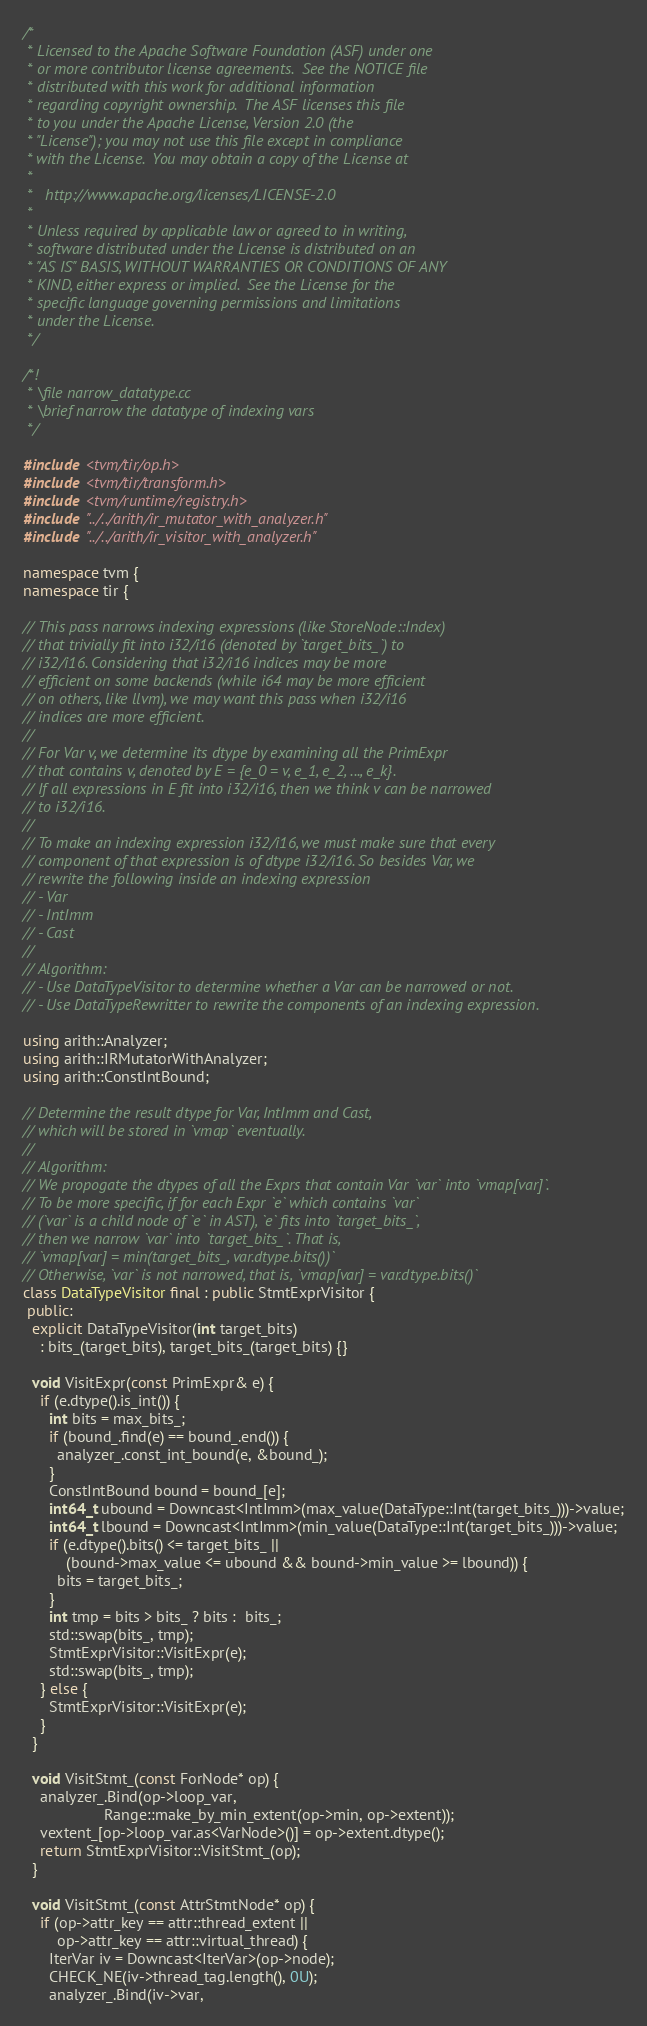Convert code to text. <code><loc_0><loc_0><loc_500><loc_500><_C++_>/*
 * Licensed to the Apache Software Foundation (ASF) under one
 * or more contributor license agreements.  See the NOTICE file
 * distributed with this work for additional information
 * regarding copyright ownership.  The ASF licenses this file
 * to you under the Apache License, Version 2.0 (the
 * "License"); you may not use this file except in compliance
 * with the License.  You may obtain a copy of the License at
 *
 *   http://www.apache.org/licenses/LICENSE-2.0
 *
 * Unless required by applicable law or agreed to in writing,
 * software distributed under the License is distributed on an
 * "AS IS" BASIS, WITHOUT WARRANTIES OR CONDITIONS OF ANY
 * KIND, either express or implied.  See the License for the
 * specific language governing permissions and limitations
 * under the License.
 */

/*!
 * \file narrow_datatype.cc
 * \brief narrow the datatype of indexing vars
 */

#include <tvm/tir/op.h>
#include <tvm/tir/transform.h>
#include <tvm/runtime/registry.h>
#include "../../arith/ir_mutator_with_analyzer.h"
#include "../../arith/ir_visitor_with_analyzer.h"

namespace tvm {
namespace tir {

// This pass narrows indexing expressions (like StoreNode::Index)
// that trivially fit into i32/i16 (denoted by `target_bits_`) to
// i32/i16. Considering that i32/i16 indices may be more
// efficient on some backends (while i64 may be more efficient
// on others, like llvm), we may want this pass when i32/i16
// indices are more efficient.
//
// For Var v, we determine its dtype by examining all the PrimExpr
// that contains v, denoted by E = {e_0 = v, e_1, e_2, ..., e_k}.
// If all expressions in E fit into i32/i16, then we think v can be narrowed
// to i32/i16.
//
// To make an indexing expression i32/i16, we must make sure that every
// component of that expression is of dtype i32/i16. So besides Var, we
// rewrite the following inside an indexing expression
// - Var
// - IntImm
// - Cast
//
// Algorithm:
// - Use DataTypeVisitor to determine whether a Var can be narrowed or not.
// - Use DataTypeRewritter to rewrite the components of an indexing expression.

using arith::Analyzer;
using arith::IRMutatorWithAnalyzer;
using arith::ConstIntBound;

// Determine the result dtype for Var, IntImm and Cast,
// which will be stored in `vmap` eventually.
//
// Algorithm:
// We propogate the dtypes of all the Exprs that contain Var `var` into `vmap[var]`.
// To be more specific, if for each Expr `e` which contains `var`
// (`var` is a child node of `e` in AST), `e` fits into `target_bits_`,
// then we narrow `var` into `target_bits_`. That is,
// `vmap[var] = min(target_bits_, var.dtype.bits())`
// Otherwise, `var` is not narrowed, that is, `vmap[var] = var.dtype.bits()`
class DataTypeVisitor final : public StmtExprVisitor {
 public:
  explicit DataTypeVisitor(int target_bits)
    : bits_(target_bits), target_bits_(target_bits) {}

  void VisitExpr(const PrimExpr& e) {
    if (e.dtype().is_int()) {
      int bits = max_bits_;
      if (bound_.find(e) == bound_.end()) {
        analyzer_.const_int_bound(e, &bound_);
      }
      ConstIntBound bound = bound_[e];
      int64_t ubound = Downcast<IntImm>(max_value(DataType::Int(target_bits_)))->value;
      int64_t lbound = Downcast<IntImm>(min_value(DataType::Int(target_bits_)))->value;
      if (e.dtype().bits() <= target_bits_ ||
          (bound->max_value <= ubound && bound->min_value >= lbound)) {
        bits = target_bits_;
      }
      int tmp = bits > bits_ ? bits :  bits_;
      std::swap(bits_, tmp);
      StmtExprVisitor::VisitExpr(e);
      std::swap(bits_, tmp);
    } else {
      StmtExprVisitor::VisitExpr(e);
    }
  }

  void VisitStmt_(const ForNode* op) {
    analyzer_.Bind(op->loop_var,
                   Range::make_by_min_extent(op->min, op->extent));
    vextent_[op->loop_var.as<VarNode>()] = op->extent.dtype();
    return StmtExprVisitor::VisitStmt_(op);
  }

  void VisitStmt_(const AttrStmtNode* op) {
    if (op->attr_key == attr::thread_extent ||
        op->attr_key == attr::virtual_thread) {
      IterVar iv = Downcast<IterVar>(op->node);
      CHECK_NE(iv->thread_tag.length(), 0U);
      analyzer_.Bind(iv->var,</code> 